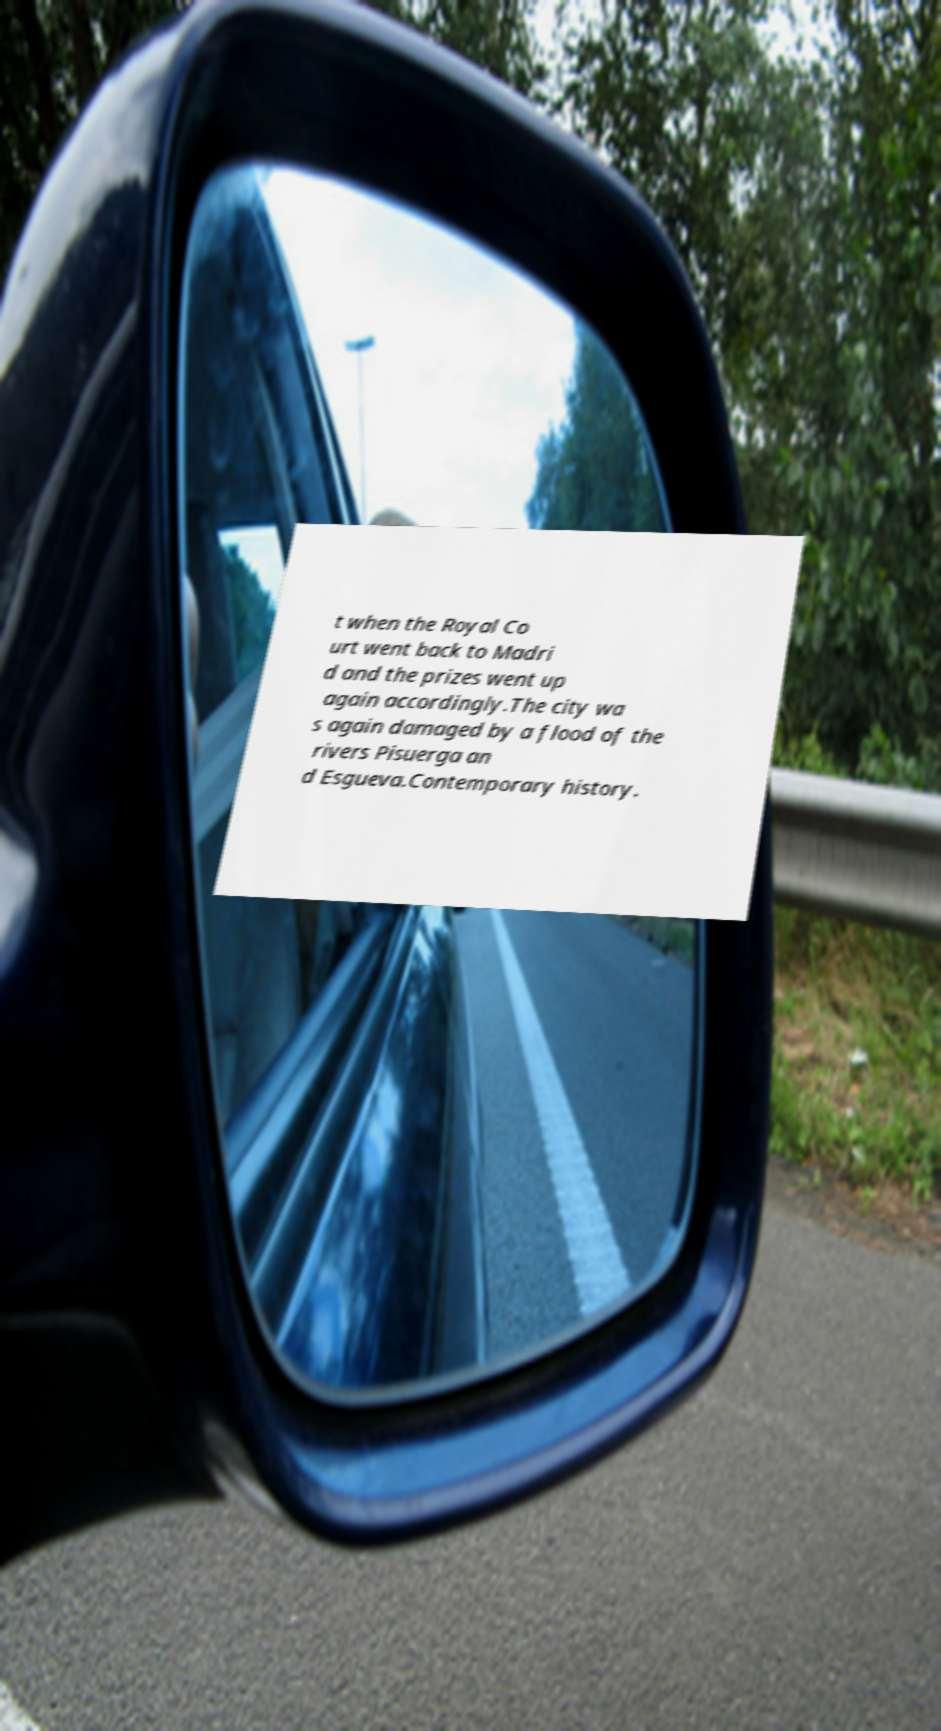Can you accurately transcribe the text from the provided image for me? t when the Royal Co urt went back to Madri d and the prizes went up again accordingly.The city wa s again damaged by a flood of the rivers Pisuerga an d Esgueva.Contemporary history. 